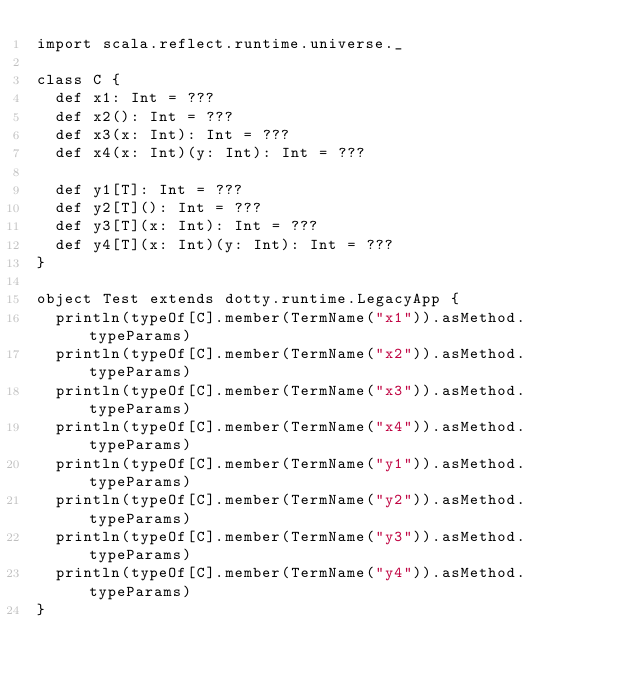Convert code to text. <code><loc_0><loc_0><loc_500><loc_500><_Scala_>import scala.reflect.runtime.universe._

class C {
  def x1: Int = ???
  def x2(): Int = ???
  def x3(x: Int): Int = ???
  def x4(x: Int)(y: Int): Int = ???

  def y1[T]: Int = ???
  def y2[T](): Int = ???
  def y3[T](x: Int): Int = ???
  def y4[T](x: Int)(y: Int): Int = ???
}

object Test extends dotty.runtime.LegacyApp {
  println(typeOf[C].member(TermName("x1")).asMethod.typeParams)
  println(typeOf[C].member(TermName("x2")).asMethod.typeParams)
  println(typeOf[C].member(TermName("x3")).asMethod.typeParams)
  println(typeOf[C].member(TermName("x4")).asMethod.typeParams)
  println(typeOf[C].member(TermName("y1")).asMethod.typeParams)
  println(typeOf[C].member(TermName("y2")).asMethod.typeParams)
  println(typeOf[C].member(TermName("y3")).asMethod.typeParams)
  println(typeOf[C].member(TermName("y4")).asMethod.typeParams)
}
</code> 